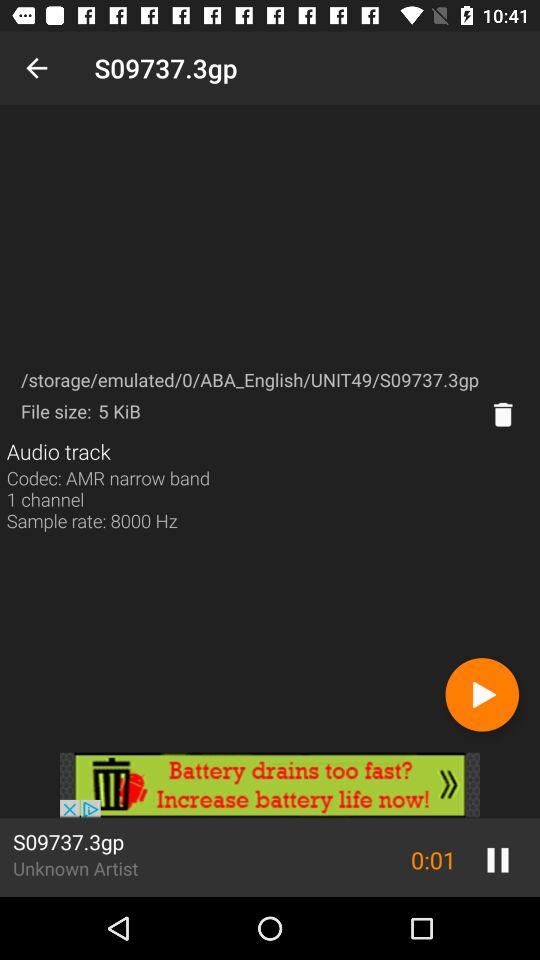What is the sample rate of the audio track?
Answer the question using a single word or phrase. 8000 Hz 